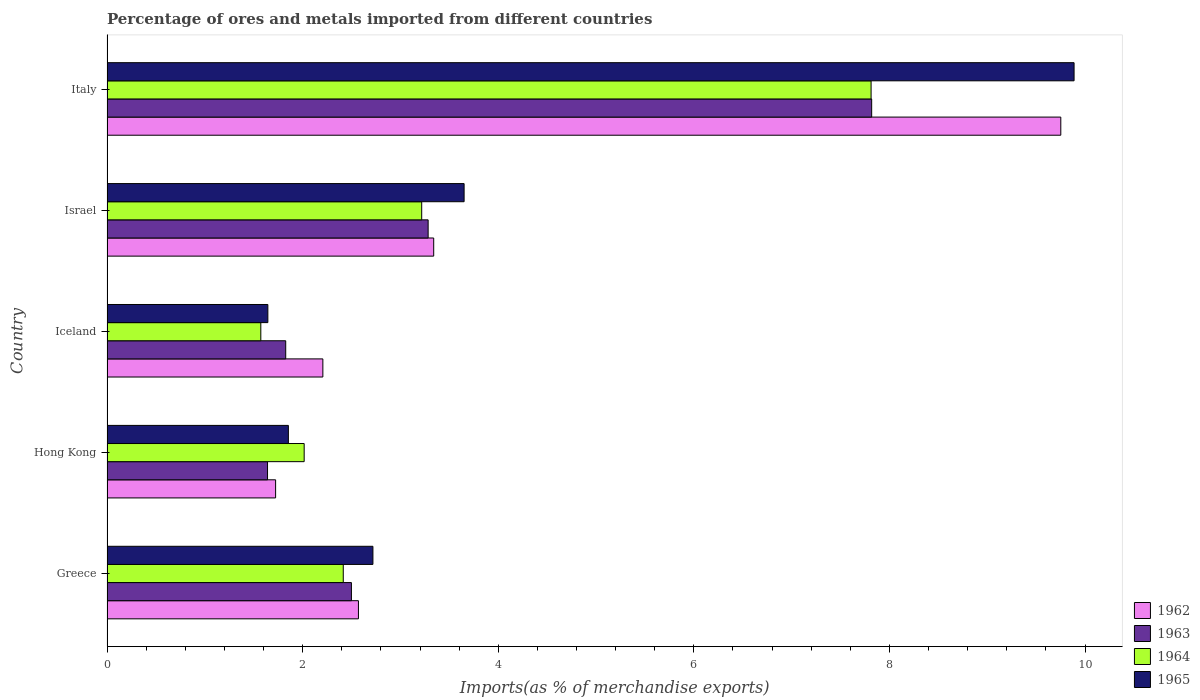How many different coloured bars are there?
Offer a terse response. 4. How many groups of bars are there?
Offer a very short reply. 5. Are the number of bars on each tick of the Y-axis equal?
Your response must be concise. Yes. What is the label of the 1st group of bars from the top?
Your answer should be very brief. Italy. What is the percentage of imports to different countries in 1965 in Greece?
Keep it short and to the point. 2.72. Across all countries, what is the maximum percentage of imports to different countries in 1965?
Offer a terse response. 9.89. Across all countries, what is the minimum percentage of imports to different countries in 1965?
Give a very brief answer. 1.64. In which country was the percentage of imports to different countries in 1963 minimum?
Keep it short and to the point. Hong Kong. What is the total percentage of imports to different countries in 1962 in the graph?
Your response must be concise. 19.59. What is the difference between the percentage of imports to different countries in 1965 in Hong Kong and that in Iceland?
Offer a terse response. 0.21. What is the difference between the percentage of imports to different countries in 1964 in Italy and the percentage of imports to different countries in 1963 in Iceland?
Your answer should be compact. 5.98. What is the average percentage of imports to different countries in 1963 per country?
Provide a succinct answer. 3.41. What is the difference between the percentage of imports to different countries in 1962 and percentage of imports to different countries in 1964 in Iceland?
Provide a short and direct response. 0.63. What is the ratio of the percentage of imports to different countries in 1962 in Hong Kong to that in Italy?
Make the answer very short. 0.18. Is the percentage of imports to different countries in 1963 in Hong Kong less than that in Italy?
Give a very brief answer. Yes. Is the difference between the percentage of imports to different countries in 1962 in Greece and Iceland greater than the difference between the percentage of imports to different countries in 1964 in Greece and Iceland?
Provide a succinct answer. No. What is the difference between the highest and the second highest percentage of imports to different countries in 1965?
Make the answer very short. 6.24. What is the difference between the highest and the lowest percentage of imports to different countries in 1962?
Keep it short and to the point. 8.03. In how many countries, is the percentage of imports to different countries in 1965 greater than the average percentage of imports to different countries in 1965 taken over all countries?
Offer a very short reply. 1. Is it the case that in every country, the sum of the percentage of imports to different countries in 1965 and percentage of imports to different countries in 1962 is greater than the sum of percentage of imports to different countries in 1964 and percentage of imports to different countries in 1963?
Your answer should be compact. No. Is it the case that in every country, the sum of the percentage of imports to different countries in 1964 and percentage of imports to different countries in 1962 is greater than the percentage of imports to different countries in 1965?
Your answer should be compact. Yes. Are all the bars in the graph horizontal?
Your response must be concise. Yes. How many countries are there in the graph?
Your answer should be very brief. 5. What is the difference between two consecutive major ticks on the X-axis?
Your answer should be very brief. 2. Are the values on the major ticks of X-axis written in scientific E-notation?
Provide a succinct answer. No. Does the graph contain any zero values?
Offer a terse response. No. Does the graph contain grids?
Give a very brief answer. No. How many legend labels are there?
Your answer should be compact. 4. What is the title of the graph?
Give a very brief answer. Percentage of ores and metals imported from different countries. Does "1964" appear as one of the legend labels in the graph?
Provide a short and direct response. Yes. What is the label or title of the X-axis?
Provide a short and direct response. Imports(as % of merchandise exports). What is the Imports(as % of merchandise exports) of 1962 in Greece?
Your answer should be compact. 2.57. What is the Imports(as % of merchandise exports) in 1963 in Greece?
Keep it short and to the point. 2.5. What is the Imports(as % of merchandise exports) of 1964 in Greece?
Your answer should be very brief. 2.42. What is the Imports(as % of merchandise exports) of 1965 in Greece?
Ensure brevity in your answer.  2.72. What is the Imports(as % of merchandise exports) in 1962 in Hong Kong?
Provide a succinct answer. 1.72. What is the Imports(as % of merchandise exports) in 1963 in Hong Kong?
Your response must be concise. 1.64. What is the Imports(as % of merchandise exports) in 1964 in Hong Kong?
Your answer should be very brief. 2.02. What is the Imports(as % of merchandise exports) of 1965 in Hong Kong?
Make the answer very short. 1.85. What is the Imports(as % of merchandise exports) in 1962 in Iceland?
Make the answer very short. 2.21. What is the Imports(as % of merchandise exports) of 1963 in Iceland?
Your answer should be very brief. 1.83. What is the Imports(as % of merchandise exports) of 1964 in Iceland?
Give a very brief answer. 1.57. What is the Imports(as % of merchandise exports) in 1965 in Iceland?
Your answer should be very brief. 1.64. What is the Imports(as % of merchandise exports) of 1962 in Israel?
Keep it short and to the point. 3.34. What is the Imports(as % of merchandise exports) in 1963 in Israel?
Keep it short and to the point. 3.28. What is the Imports(as % of merchandise exports) of 1964 in Israel?
Your answer should be compact. 3.22. What is the Imports(as % of merchandise exports) of 1965 in Israel?
Keep it short and to the point. 3.65. What is the Imports(as % of merchandise exports) in 1962 in Italy?
Your response must be concise. 9.75. What is the Imports(as % of merchandise exports) in 1963 in Italy?
Give a very brief answer. 7.82. What is the Imports(as % of merchandise exports) in 1964 in Italy?
Your answer should be compact. 7.81. What is the Imports(as % of merchandise exports) in 1965 in Italy?
Give a very brief answer. 9.89. Across all countries, what is the maximum Imports(as % of merchandise exports) in 1962?
Your answer should be very brief. 9.75. Across all countries, what is the maximum Imports(as % of merchandise exports) in 1963?
Ensure brevity in your answer.  7.82. Across all countries, what is the maximum Imports(as % of merchandise exports) of 1964?
Make the answer very short. 7.81. Across all countries, what is the maximum Imports(as % of merchandise exports) of 1965?
Offer a terse response. 9.89. Across all countries, what is the minimum Imports(as % of merchandise exports) of 1962?
Make the answer very short. 1.72. Across all countries, what is the minimum Imports(as % of merchandise exports) in 1963?
Ensure brevity in your answer.  1.64. Across all countries, what is the minimum Imports(as % of merchandise exports) of 1964?
Your answer should be compact. 1.57. Across all countries, what is the minimum Imports(as % of merchandise exports) of 1965?
Make the answer very short. 1.64. What is the total Imports(as % of merchandise exports) of 1962 in the graph?
Provide a succinct answer. 19.59. What is the total Imports(as % of merchandise exports) in 1963 in the graph?
Provide a short and direct response. 17.07. What is the total Imports(as % of merchandise exports) of 1964 in the graph?
Your answer should be compact. 17.03. What is the total Imports(as % of merchandise exports) in 1965 in the graph?
Your answer should be very brief. 19.76. What is the difference between the Imports(as % of merchandise exports) of 1962 in Greece and that in Hong Kong?
Provide a succinct answer. 0.85. What is the difference between the Imports(as % of merchandise exports) in 1963 in Greece and that in Hong Kong?
Make the answer very short. 0.86. What is the difference between the Imports(as % of merchandise exports) of 1964 in Greece and that in Hong Kong?
Keep it short and to the point. 0.4. What is the difference between the Imports(as % of merchandise exports) of 1965 in Greece and that in Hong Kong?
Ensure brevity in your answer.  0.86. What is the difference between the Imports(as % of merchandise exports) in 1962 in Greece and that in Iceland?
Make the answer very short. 0.36. What is the difference between the Imports(as % of merchandise exports) of 1963 in Greece and that in Iceland?
Make the answer very short. 0.67. What is the difference between the Imports(as % of merchandise exports) in 1964 in Greece and that in Iceland?
Make the answer very short. 0.84. What is the difference between the Imports(as % of merchandise exports) in 1965 in Greece and that in Iceland?
Your answer should be compact. 1.07. What is the difference between the Imports(as % of merchandise exports) of 1962 in Greece and that in Israel?
Keep it short and to the point. -0.77. What is the difference between the Imports(as % of merchandise exports) in 1963 in Greece and that in Israel?
Provide a short and direct response. -0.78. What is the difference between the Imports(as % of merchandise exports) of 1964 in Greece and that in Israel?
Offer a terse response. -0.8. What is the difference between the Imports(as % of merchandise exports) in 1965 in Greece and that in Israel?
Your answer should be compact. -0.93. What is the difference between the Imports(as % of merchandise exports) in 1962 in Greece and that in Italy?
Offer a very short reply. -7.18. What is the difference between the Imports(as % of merchandise exports) of 1963 in Greece and that in Italy?
Give a very brief answer. -5.32. What is the difference between the Imports(as % of merchandise exports) of 1964 in Greece and that in Italy?
Your answer should be compact. -5.4. What is the difference between the Imports(as % of merchandise exports) of 1965 in Greece and that in Italy?
Make the answer very short. -7.17. What is the difference between the Imports(as % of merchandise exports) in 1962 in Hong Kong and that in Iceland?
Your answer should be very brief. -0.48. What is the difference between the Imports(as % of merchandise exports) of 1963 in Hong Kong and that in Iceland?
Keep it short and to the point. -0.19. What is the difference between the Imports(as % of merchandise exports) in 1964 in Hong Kong and that in Iceland?
Ensure brevity in your answer.  0.44. What is the difference between the Imports(as % of merchandise exports) of 1965 in Hong Kong and that in Iceland?
Your answer should be compact. 0.21. What is the difference between the Imports(as % of merchandise exports) in 1962 in Hong Kong and that in Israel?
Keep it short and to the point. -1.62. What is the difference between the Imports(as % of merchandise exports) of 1963 in Hong Kong and that in Israel?
Provide a succinct answer. -1.64. What is the difference between the Imports(as % of merchandise exports) in 1964 in Hong Kong and that in Israel?
Your answer should be very brief. -1.2. What is the difference between the Imports(as % of merchandise exports) of 1965 in Hong Kong and that in Israel?
Offer a terse response. -1.8. What is the difference between the Imports(as % of merchandise exports) in 1962 in Hong Kong and that in Italy?
Offer a terse response. -8.03. What is the difference between the Imports(as % of merchandise exports) in 1963 in Hong Kong and that in Italy?
Provide a short and direct response. -6.18. What is the difference between the Imports(as % of merchandise exports) of 1964 in Hong Kong and that in Italy?
Give a very brief answer. -5.8. What is the difference between the Imports(as % of merchandise exports) of 1965 in Hong Kong and that in Italy?
Keep it short and to the point. -8.03. What is the difference between the Imports(as % of merchandise exports) in 1962 in Iceland and that in Israel?
Offer a terse response. -1.13. What is the difference between the Imports(as % of merchandise exports) of 1963 in Iceland and that in Israel?
Your response must be concise. -1.46. What is the difference between the Imports(as % of merchandise exports) in 1964 in Iceland and that in Israel?
Ensure brevity in your answer.  -1.65. What is the difference between the Imports(as % of merchandise exports) of 1965 in Iceland and that in Israel?
Keep it short and to the point. -2.01. What is the difference between the Imports(as % of merchandise exports) in 1962 in Iceland and that in Italy?
Offer a terse response. -7.54. What is the difference between the Imports(as % of merchandise exports) of 1963 in Iceland and that in Italy?
Give a very brief answer. -5.99. What is the difference between the Imports(as % of merchandise exports) of 1964 in Iceland and that in Italy?
Your answer should be very brief. -6.24. What is the difference between the Imports(as % of merchandise exports) of 1965 in Iceland and that in Italy?
Your response must be concise. -8.24. What is the difference between the Imports(as % of merchandise exports) in 1962 in Israel and that in Italy?
Your answer should be very brief. -6.41. What is the difference between the Imports(as % of merchandise exports) of 1963 in Israel and that in Italy?
Your answer should be compact. -4.53. What is the difference between the Imports(as % of merchandise exports) in 1964 in Israel and that in Italy?
Provide a short and direct response. -4.59. What is the difference between the Imports(as % of merchandise exports) in 1965 in Israel and that in Italy?
Provide a short and direct response. -6.24. What is the difference between the Imports(as % of merchandise exports) in 1962 in Greece and the Imports(as % of merchandise exports) in 1963 in Hong Kong?
Provide a short and direct response. 0.93. What is the difference between the Imports(as % of merchandise exports) of 1962 in Greece and the Imports(as % of merchandise exports) of 1964 in Hong Kong?
Make the answer very short. 0.55. What is the difference between the Imports(as % of merchandise exports) in 1962 in Greece and the Imports(as % of merchandise exports) in 1965 in Hong Kong?
Offer a terse response. 0.72. What is the difference between the Imports(as % of merchandise exports) in 1963 in Greece and the Imports(as % of merchandise exports) in 1964 in Hong Kong?
Your answer should be very brief. 0.48. What is the difference between the Imports(as % of merchandise exports) in 1963 in Greece and the Imports(as % of merchandise exports) in 1965 in Hong Kong?
Your answer should be very brief. 0.64. What is the difference between the Imports(as % of merchandise exports) in 1964 in Greece and the Imports(as % of merchandise exports) in 1965 in Hong Kong?
Keep it short and to the point. 0.56. What is the difference between the Imports(as % of merchandise exports) in 1962 in Greece and the Imports(as % of merchandise exports) in 1963 in Iceland?
Offer a very short reply. 0.74. What is the difference between the Imports(as % of merchandise exports) in 1962 in Greece and the Imports(as % of merchandise exports) in 1964 in Iceland?
Make the answer very short. 1. What is the difference between the Imports(as % of merchandise exports) in 1962 in Greece and the Imports(as % of merchandise exports) in 1965 in Iceland?
Provide a succinct answer. 0.93. What is the difference between the Imports(as % of merchandise exports) of 1963 in Greece and the Imports(as % of merchandise exports) of 1964 in Iceland?
Give a very brief answer. 0.93. What is the difference between the Imports(as % of merchandise exports) of 1963 in Greece and the Imports(as % of merchandise exports) of 1965 in Iceland?
Provide a short and direct response. 0.85. What is the difference between the Imports(as % of merchandise exports) in 1964 in Greece and the Imports(as % of merchandise exports) in 1965 in Iceland?
Your answer should be very brief. 0.77. What is the difference between the Imports(as % of merchandise exports) in 1962 in Greece and the Imports(as % of merchandise exports) in 1963 in Israel?
Give a very brief answer. -0.71. What is the difference between the Imports(as % of merchandise exports) in 1962 in Greece and the Imports(as % of merchandise exports) in 1964 in Israel?
Your response must be concise. -0.65. What is the difference between the Imports(as % of merchandise exports) in 1962 in Greece and the Imports(as % of merchandise exports) in 1965 in Israel?
Your response must be concise. -1.08. What is the difference between the Imports(as % of merchandise exports) of 1963 in Greece and the Imports(as % of merchandise exports) of 1964 in Israel?
Offer a very short reply. -0.72. What is the difference between the Imports(as % of merchandise exports) of 1963 in Greece and the Imports(as % of merchandise exports) of 1965 in Israel?
Give a very brief answer. -1.15. What is the difference between the Imports(as % of merchandise exports) of 1964 in Greece and the Imports(as % of merchandise exports) of 1965 in Israel?
Offer a very short reply. -1.24. What is the difference between the Imports(as % of merchandise exports) in 1962 in Greece and the Imports(as % of merchandise exports) in 1963 in Italy?
Make the answer very short. -5.25. What is the difference between the Imports(as % of merchandise exports) of 1962 in Greece and the Imports(as % of merchandise exports) of 1964 in Italy?
Offer a terse response. -5.24. What is the difference between the Imports(as % of merchandise exports) in 1962 in Greece and the Imports(as % of merchandise exports) in 1965 in Italy?
Provide a short and direct response. -7.32. What is the difference between the Imports(as % of merchandise exports) of 1963 in Greece and the Imports(as % of merchandise exports) of 1964 in Italy?
Offer a very short reply. -5.31. What is the difference between the Imports(as % of merchandise exports) in 1963 in Greece and the Imports(as % of merchandise exports) in 1965 in Italy?
Your answer should be compact. -7.39. What is the difference between the Imports(as % of merchandise exports) in 1964 in Greece and the Imports(as % of merchandise exports) in 1965 in Italy?
Your answer should be very brief. -7.47. What is the difference between the Imports(as % of merchandise exports) of 1962 in Hong Kong and the Imports(as % of merchandise exports) of 1963 in Iceland?
Make the answer very short. -0.1. What is the difference between the Imports(as % of merchandise exports) in 1962 in Hong Kong and the Imports(as % of merchandise exports) in 1964 in Iceland?
Keep it short and to the point. 0.15. What is the difference between the Imports(as % of merchandise exports) in 1962 in Hong Kong and the Imports(as % of merchandise exports) in 1965 in Iceland?
Your response must be concise. 0.08. What is the difference between the Imports(as % of merchandise exports) in 1963 in Hong Kong and the Imports(as % of merchandise exports) in 1964 in Iceland?
Provide a short and direct response. 0.07. What is the difference between the Imports(as % of merchandise exports) of 1963 in Hong Kong and the Imports(as % of merchandise exports) of 1965 in Iceland?
Provide a succinct answer. -0. What is the difference between the Imports(as % of merchandise exports) in 1964 in Hong Kong and the Imports(as % of merchandise exports) in 1965 in Iceland?
Give a very brief answer. 0.37. What is the difference between the Imports(as % of merchandise exports) of 1962 in Hong Kong and the Imports(as % of merchandise exports) of 1963 in Israel?
Your answer should be very brief. -1.56. What is the difference between the Imports(as % of merchandise exports) in 1962 in Hong Kong and the Imports(as % of merchandise exports) in 1964 in Israel?
Keep it short and to the point. -1.49. What is the difference between the Imports(as % of merchandise exports) of 1962 in Hong Kong and the Imports(as % of merchandise exports) of 1965 in Israel?
Your response must be concise. -1.93. What is the difference between the Imports(as % of merchandise exports) of 1963 in Hong Kong and the Imports(as % of merchandise exports) of 1964 in Israel?
Keep it short and to the point. -1.58. What is the difference between the Imports(as % of merchandise exports) in 1963 in Hong Kong and the Imports(as % of merchandise exports) in 1965 in Israel?
Ensure brevity in your answer.  -2.01. What is the difference between the Imports(as % of merchandise exports) in 1964 in Hong Kong and the Imports(as % of merchandise exports) in 1965 in Israel?
Your answer should be compact. -1.64. What is the difference between the Imports(as % of merchandise exports) in 1962 in Hong Kong and the Imports(as % of merchandise exports) in 1963 in Italy?
Give a very brief answer. -6.09. What is the difference between the Imports(as % of merchandise exports) of 1962 in Hong Kong and the Imports(as % of merchandise exports) of 1964 in Italy?
Your answer should be compact. -6.09. What is the difference between the Imports(as % of merchandise exports) in 1962 in Hong Kong and the Imports(as % of merchandise exports) in 1965 in Italy?
Offer a terse response. -8.16. What is the difference between the Imports(as % of merchandise exports) in 1963 in Hong Kong and the Imports(as % of merchandise exports) in 1964 in Italy?
Make the answer very short. -6.17. What is the difference between the Imports(as % of merchandise exports) of 1963 in Hong Kong and the Imports(as % of merchandise exports) of 1965 in Italy?
Provide a short and direct response. -8.25. What is the difference between the Imports(as % of merchandise exports) of 1964 in Hong Kong and the Imports(as % of merchandise exports) of 1965 in Italy?
Keep it short and to the point. -7.87. What is the difference between the Imports(as % of merchandise exports) in 1962 in Iceland and the Imports(as % of merchandise exports) in 1963 in Israel?
Your answer should be compact. -1.08. What is the difference between the Imports(as % of merchandise exports) in 1962 in Iceland and the Imports(as % of merchandise exports) in 1964 in Israel?
Ensure brevity in your answer.  -1.01. What is the difference between the Imports(as % of merchandise exports) of 1962 in Iceland and the Imports(as % of merchandise exports) of 1965 in Israel?
Offer a very short reply. -1.44. What is the difference between the Imports(as % of merchandise exports) in 1963 in Iceland and the Imports(as % of merchandise exports) in 1964 in Israel?
Your answer should be compact. -1.39. What is the difference between the Imports(as % of merchandise exports) in 1963 in Iceland and the Imports(as % of merchandise exports) in 1965 in Israel?
Offer a terse response. -1.82. What is the difference between the Imports(as % of merchandise exports) of 1964 in Iceland and the Imports(as % of merchandise exports) of 1965 in Israel?
Keep it short and to the point. -2.08. What is the difference between the Imports(as % of merchandise exports) in 1962 in Iceland and the Imports(as % of merchandise exports) in 1963 in Italy?
Give a very brief answer. -5.61. What is the difference between the Imports(as % of merchandise exports) of 1962 in Iceland and the Imports(as % of merchandise exports) of 1964 in Italy?
Keep it short and to the point. -5.61. What is the difference between the Imports(as % of merchandise exports) in 1962 in Iceland and the Imports(as % of merchandise exports) in 1965 in Italy?
Your answer should be compact. -7.68. What is the difference between the Imports(as % of merchandise exports) of 1963 in Iceland and the Imports(as % of merchandise exports) of 1964 in Italy?
Provide a succinct answer. -5.98. What is the difference between the Imports(as % of merchandise exports) in 1963 in Iceland and the Imports(as % of merchandise exports) in 1965 in Italy?
Your answer should be very brief. -8.06. What is the difference between the Imports(as % of merchandise exports) in 1964 in Iceland and the Imports(as % of merchandise exports) in 1965 in Italy?
Provide a succinct answer. -8.31. What is the difference between the Imports(as % of merchandise exports) of 1962 in Israel and the Imports(as % of merchandise exports) of 1963 in Italy?
Keep it short and to the point. -4.48. What is the difference between the Imports(as % of merchandise exports) in 1962 in Israel and the Imports(as % of merchandise exports) in 1964 in Italy?
Offer a terse response. -4.47. What is the difference between the Imports(as % of merchandise exports) in 1962 in Israel and the Imports(as % of merchandise exports) in 1965 in Italy?
Your answer should be very brief. -6.55. What is the difference between the Imports(as % of merchandise exports) in 1963 in Israel and the Imports(as % of merchandise exports) in 1964 in Italy?
Offer a very short reply. -4.53. What is the difference between the Imports(as % of merchandise exports) in 1963 in Israel and the Imports(as % of merchandise exports) in 1965 in Italy?
Your response must be concise. -6.6. What is the difference between the Imports(as % of merchandise exports) in 1964 in Israel and the Imports(as % of merchandise exports) in 1965 in Italy?
Provide a succinct answer. -6.67. What is the average Imports(as % of merchandise exports) of 1962 per country?
Make the answer very short. 3.92. What is the average Imports(as % of merchandise exports) in 1963 per country?
Keep it short and to the point. 3.41. What is the average Imports(as % of merchandise exports) in 1964 per country?
Ensure brevity in your answer.  3.41. What is the average Imports(as % of merchandise exports) of 1965 per country?
Give a very brief answer. 3.95. What is the difference between the Imports(as % of merchandise exports) of 1962 and Imports(as % of merchandise exports) of 1963 in Greece?
Keep it short and to the point. 0.07. What is the difference between the Imports(as % of merchandise exports) in 1962 and Imports(as % of merchandise exports) in 1964 in Greece?
Give a very brief answer. 0.16. What is the difference between the Imports(as % of merchandise exports) of 1962 and Imports(as % of merchandise exports) of 1965 in Greece?
Provide a succinct answer. -0.15. What is the difference between the Imports(as % of merchandise exports) of 1963 and Imports(as % of merchandise exports) of 1964 in Greece?
Give a very brief answer. 0.08. What is the difference between the Imports(as % of merchandise exports) in 1963 and Imports(as % of merchandise exports) in 1965 in Greece?
Keep it short and to the point. -0.22. What is the difference between the Imports(as % of merchandise exports) of 1964 and Imports(as % of merchandise exports) of 1965 in Greece?
Offer a very short reply. -0.3. What is the difference between the Imports(as % of merchandise exports) of 1962 and Imports(as % of merchandise exports) of 1963 in Hong Kong?
Keep it short and to the point. 0.08. What is the difference between the Imports(as % of merchandise exports) of 1962 and Imports(as % of merchandise exports) of 1964 in Hong Kong?
Provide a short and direct response. -0.29. What is the difference between the Imports(as % of merchandise exports) of 1962 and Imports(as % of merchandise exports) of 1965 in Hong Kong?
Provide a short and direct response. -0.13. What is the difference between the Imports(as % of merchandise exports) in 1963 and Imports(as % of merchandise exports) in 1964 in Hong Kong?
Make the answer very short. -0.37. What is the difference between the Imports(as % of merchandise exports) of 1963 and Imports(as % of merchandise exports) of 1965 in Hong Kong?
Offer a very short reply. -0.21. What is the difference between the Imports(as % of merchandise exports) in 1964 and Imports(as % of merchandise exports) in 1965 in Hong Kong?
Offer a very short reply. 0.16. What is the difference between the Imports(as % of merchandise exports) of 1962 and Imports(as % of merchandise exports) of 1963 in Iceland?
Offer a terse response. 0.38. What is the difference between the Imports(as % of merchandise exports) in 1962 and Imports(as % of merchandise exports) in 1964 in Iceland?
Keep it short and to the point. 0.63. What is the difference between the Imports(as % of merchandise exports) of 1962 and Imports(as % of merchandise exports) of 1965 in Iceland?
Your response must be concise. 0.56. What is the difference between the Imports(as % of merchandise exports) in 1963 and Imports(as % of merchandise exports) in 1964 in Iceland?
Offer a terse response. 0.25. What is the difference between the Imports(as % of merchandise exports) in 1963 and Imports(as % of merchandise exports) in 1965 in Iceland?
Give a very brief answer. 0.18. What is the difference between the Imports(as % of merchandise exports) of 1964 and Imports(as % of merchandise exports) of 1965 in Iceland?
Ensure brevity in your answer.  -0.07. What is the difference between the Imports(as % of merchandise exports) of 1962 and Imports(as % of merchandise exports) of 1963 in Israel?
Your response must be concise. 0.06. What is the difference between the Imports(as % of merchandise exports) in 1962 and Imports(as % of merchandise exports) in 1964 in Israel?
Your answer should be compact. 0.12. What is the difference between the Imports(as % of merchandise exports) of 1962 and Imports(as % of merchandise exports) of 1965 in Israel?
Ensure brevity in your answer.  -0.31. What is the difference between the Imports(as % of merchandise exports) in 1963 and Imports(as % of merchandise exports) in 1964 in Israel?
Your answer should be very brief. 0.07. What is the difference between the Imports(as % of merchandise exports) of 1963 and Imports(as % of merchandise exports) of 1965 in Israel?
Provide a short and direct response. -0.37. What is the difference between the Imports(as % of merchandise exports) of 1964 and Imports(as % of merchandise exports) of 1965 in Israel?
Make the answer very short. -0.43. What is the difference between the Imports(as % of merchandise exports) in 1962 and Imports(as % of merchandise exports) in 1963 in Italy?
Offer a very short reply. 1.93. What is the difference between the Imports(as % of merchandise exports) of 1962 and Imports(as % of merchandise exports) of 1964 in Italy?
Give a very brief answer. 1.94. What is the difference between the Imports(as % of merchandise exports) of 1962 and Imports(as % of merchandise exports) of 1965 in Italy?
Keep it short and to the point. -0.14. What is the difference between the Imports(as % of merchandise exports) in 1963 and Imports(as % of merchandise exports) in 1964 in Italy?
Ensure brevity in your answer.  0.01. What is the difference between the Imports(as % of merchandise exports) of 1963 and Imports(as % of merchandise exports) of 1965 in Italy?
Make the answer very short. -2.07. What is the difference between the Imports(as % of merchandise exports) in 1964 and Imports(as % of merchandise exports) in 1965 in Italy?
Your answer should be very brief. -2.08. What is the ratio of the Imports(as % of merchandise exports) of 1962 in Greece to that in Hong Kong?
Your response must be concise. 1.49. What is the ratio of the Imports(as % of merchandise exports) in 1963 in Greece to that in Hong Kong?
Your answer should be very brief. 1.52. What is the ratio of the Imports(as % of merchandise exports) of 1964 in Greece to that in Hong Kong?
Make the answer very short. 1.2. What is the ratio of the Imports(as % of merchandise exports) of 1965 in Greece to that in Hong Kong?
Your response must be concise. 1.47. What is the ratio of the Imports(as % of merchandise exports) in 1962 in Greece to that in Iceland?
Your answer should be compact. 1.16. What is the ratio of the Imports(as % of merchandise exports) of 1963 in Greece to that in Iceland?
Keep it short and to the point. 1.37. What is the ratio of the Imports(as % of merchandise exports) in 1964 in Greece to that in Iceland?
Your answer should be very brief. 1.54. What is the ratio of the Imports(as % of merchandise exports) in 1965 in Greece to that in Iceland?
Ensure brevity in your answer.  1.65. What is the ratio of the Imports(as % of merchandise exports) in 1962 in Greece to that in Israel?
Provide a succinct answer. 0.77. What is the ratio of the Imports(as % of merchandise exports) of 1963 in Greece to that in Israel?
Your answer should be very brief. 0.76. What is the ratio of the Imports(as % of merchandise exports) in 1964 in Greece to that in Israel?
Your answer should be compact. 0.75. What is the ratio of the Imports(as % of merchandise exports) in 1965 in Greece to that in Israel?
Give a very brief answer. 0.74. What is the ratio of the Imports(as % of merchandise exports) of 1962 in Greece to that in Italy?
Keep it short and to the point. 0.26. What is the ratio of the Imports(as % of merchandise exports) of 1963 in Greece to that in Italy?
Offer a terse response. 0.32. What is the ratio of the Imports(as % of merchandise exports) of 1964 in Greece to that in Italy?
Make the answer very short. 0.31. What is the ratio of the Imports(as % of merchandise exports) of 1965 in Greece to that in Italy?
Provide a short and direct response. 0.28. What is the ratio of the Imports(as % of merchandise exports) of 1962 in Hong Kong to that in Iceland?
Your response must be concise. 0.78. What is the ratio of the Imports(as % of merchandise exports) of 1963 in Hong Kong to that in Iceland?
Keep it short and to the point. 0.9. What is the ratio of the Imports(as % of merchandise exports) of 1964 in Hong Kong to that in Iceland?
Offer a very short reply. 1.28. What is the ratio of the Imports(as % of merchandise exports) of 1965 in Hong Kong to that in Iceland?
Offer a very short reply. 1.13. What is the ratio of the Imports(as % of merchandise exports) of 1962 in Hong Kong to that in Israel?
Provide a succinct answer. 0.52. What is the ratio of the Imports(as % of merchandise exports) of 1963 in Hong Kong to that in Israel?
Keep it short and to the point. 0.5. What is the ratio of the Imports(as % of merchandise exports) in 1964 in Hong Kong to that in Israel?
Ensure brevity in your answer.  0.63. What is the ratio of the Imports(as % of merchandise exports) in 1965 in Hong Kong to that in Israel?
Your answer should be compact. 0.51. What is the ratio of the Imports(as % of merchandise exports) in 1962 in Hong Kong to that in Italy?
Provide a short and direct response. 0.18. What is the ratio of the Imports(as % of merchandise exports) in 1963 in Hong Kong to that in Italy?
Give a very brief answer. 0.21. What is the ratio of the Imports(as % of merchandise exports) in 1964 in Hong Kong to that in Italy?
Give a very brief answer. 0.26. What is the ratio of the Imports(as % of merchandise exports) in 1965 in Hong Kong to that in Italy?
Your answer should be very brief. 0.19. What is the ratio of the Imports(as % of merchandise exports) in 1962 in Iceland to that in Israel?
Give a very brief answer. 0.66. What is the ratio of the Imports(as % of merchandise exports) of 1963 in Iceland to that in Israel?
Your answer should be compact. 0.56. What is the ratio of the Imports(as % of merchandise exports) of 1964 in Iceland to that in Israel?
Ensure brevity in your answer.  0.49. What is the ratio of the Imports(as % of merchandise exports) in 1965 in Iceland to that in Israel?
Offer a very short reply. 0.45. What is the ratio of the Imports(as % of merchandise exports) of 1962 in Iceland to that in Italy?
Give a very brief answer. 0.23. What is the ratio of the Imports(as % of merchandise exports) in 1963 in Iceland to that in Italy?
Offer a very short reply. 0.23. What is the ratio of the Imports(as % of merchandise exports) of 1964 in Iceland to that in Italy?
Give a very brief answer. 0.2. What is the ratio of the Imports(as % of merchandise exports) in 1965 in Iceland to that in Italy?
Give a very brief answer. 0.17. What is the ratio of the Imports(as % of merchandise exports) of 1962 in Israel to that in Italy?
Offer a very short reply. 0.34. What is the ratio of the Imports(as % of merchandise exports) in 1963 in Israel to that in Italy?
Give a very brief answer. 0.42. What is the ratio of the Imports(as % of merchandise exports) of 1964 in Israel to that in Italy?
Keep it short and to the point. 0.41. What is the ratio of the Imports(as % of merchandise exports) in 1965 in Israel to that in Italy?
Your answer should be very brief. 0.37. What is the difference between the highest and the second highest Imports(as % of merchandise exports) of 1962?
Your response must be concise. 6.41. What is the difference between the highest and the second highest Imports(as % of merchandise exports) in 1963?
Give a very brief answer. 4.53. What is the difference between the highest and the second highest Imports(as % of merchandise exports) of 1964?
Offer a very short reply. 4.59. What is the difference between the highest and the second highest Imports(as % of merchandise exports) in 1965?
Your answer should be compact. 6.24. What is the difference between the highest and the lowest Imports(as % of merchandise exports) of 1962?
Your response must be concise. 8.03. What is the difference between the highest and the lowest Imports(as % of merchandise exports) of 1963?
Offer a very short reply. 6.18. What is the difference between the highest and the lowest Imports(as % of merchandise exports) of 1964?
Your answer should be compact. 6.24. What is the difference between the highest and the lowest Imports(as % of merchandise exports) of 1965?
Your response must be concise. 8.24. 